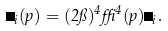<formula> <loc_0><loc_0><loc_500><loc_500>\Theta _ { i } ( p ) = ( 2 \pi ) ^ { 4 } \delta ^ { 4 } ( p ) \Theta _ { i } .</formula> 